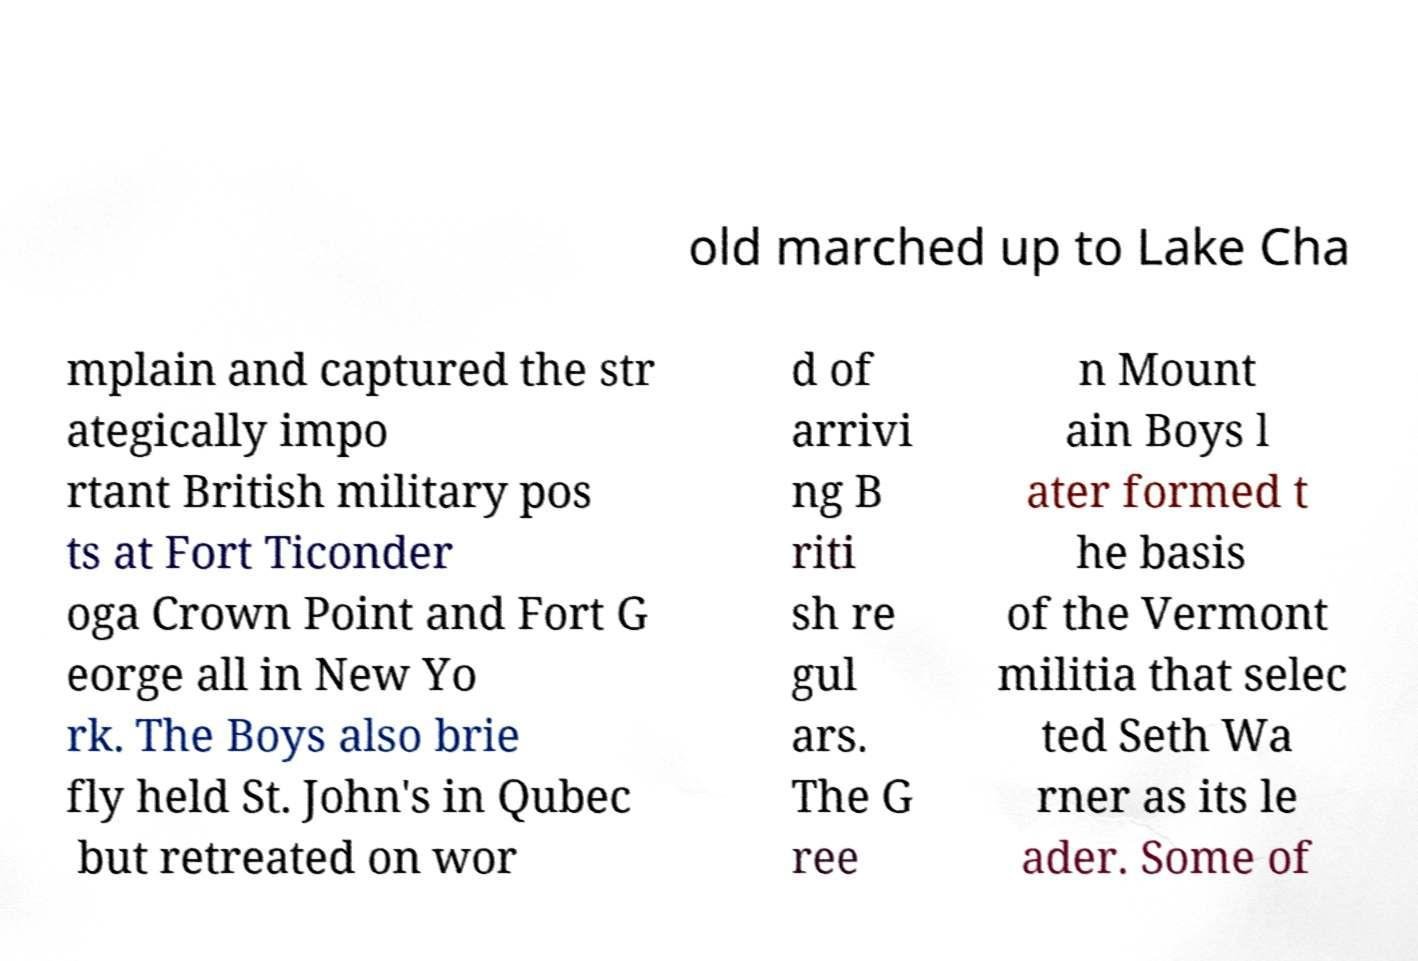For documentation purposes, I need the text within this image transcribed. Could you provide that? old marched up to Lake Cha mplain and captured the str ategically impo rtant British military pos ts at Fort Ticonder oga Crown Point and Fort G eorge all in New Yo rk. The Boys also brie fly held St. John's in Qubec but retreated on wor d of arrivi ng B riti sh re gul ars. The G ree n Mount ain Boys l ater formed t he basis of the Vermont militia that selec ted Seth Wa rner as its le ader. Some of 